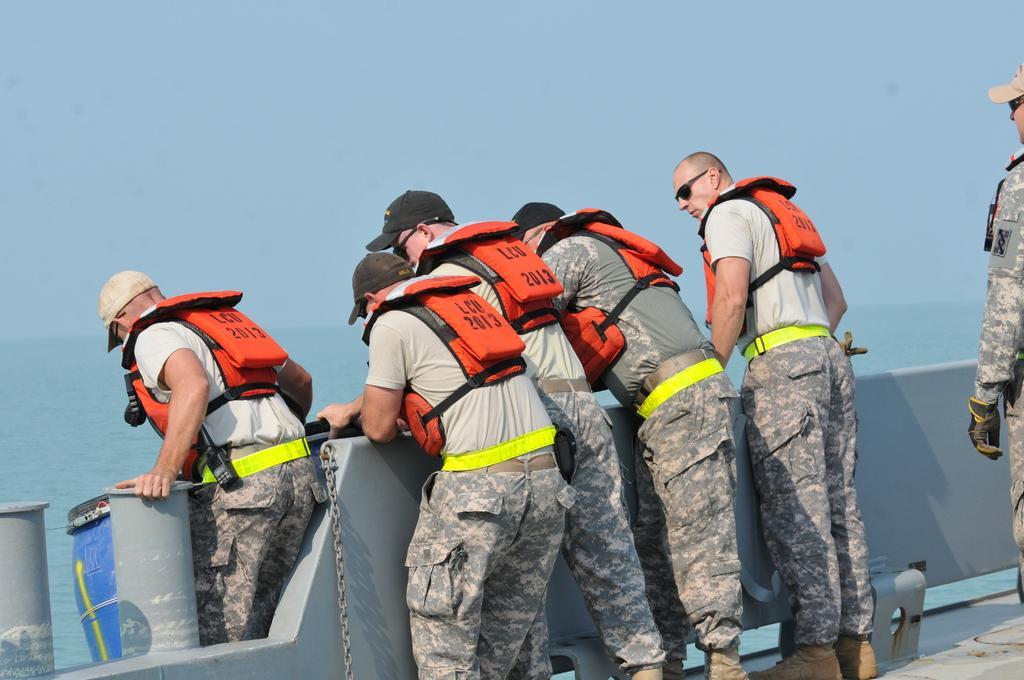Describe this image in one or two sentences. In this image there are people standing on the floor. In front of them there is a wall. There are pillars. There is a blue can. In the background of the image there is water and sky. 